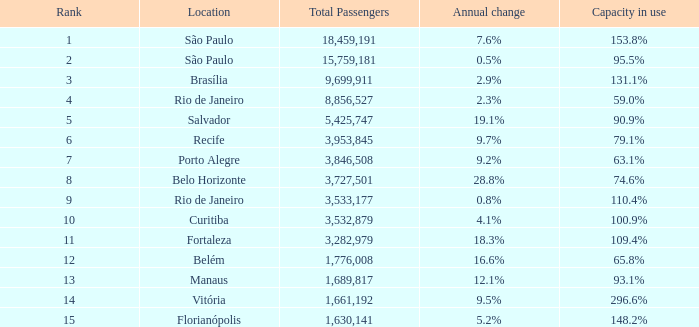What is the total number of Total Passengers when the annual change is 28.8% and the rank is less than 8? 0.0. 